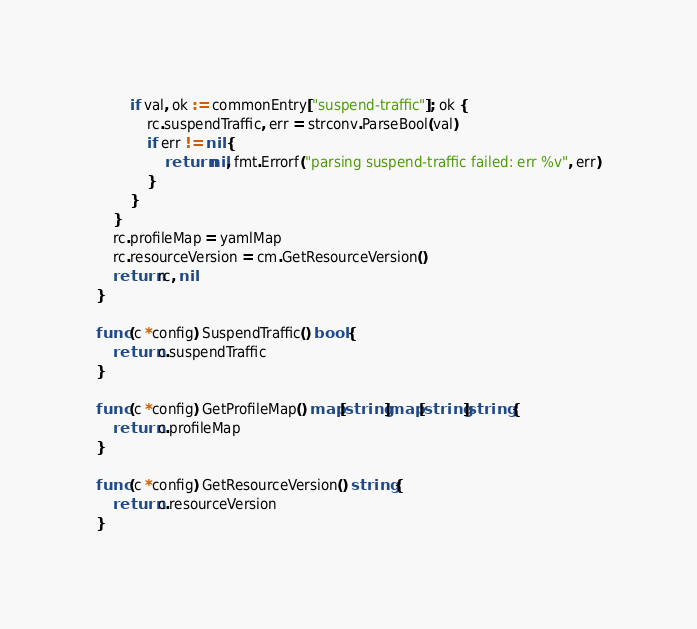<code> <loc_0><loc_0><loc_500><loc_500><_Go_>		if val, ok := commonEntry["suspend-traffic"]; ok {
			rc.suspendTraffic, err = strconv.ParseBool(val)
			if err != nil {
				return nil, fmt.Errorf("parsing suspend-traffic failed: err %v", err)
			}
		}
	}
	rc.profileMap = yamlMap
	rc.resourceVersion = cm.GetResourceVersion()
	return rc, nil
}

func (c *config) SuspendTraffic() bool {
	return c.suspendTraffic
}

func (c *config) GetProfileMap() map[string]map[string]string {
	return c.profileMap
}

func (c *config) GetResourceVersion() string {
	return c.resourceVersion
}
</code> 